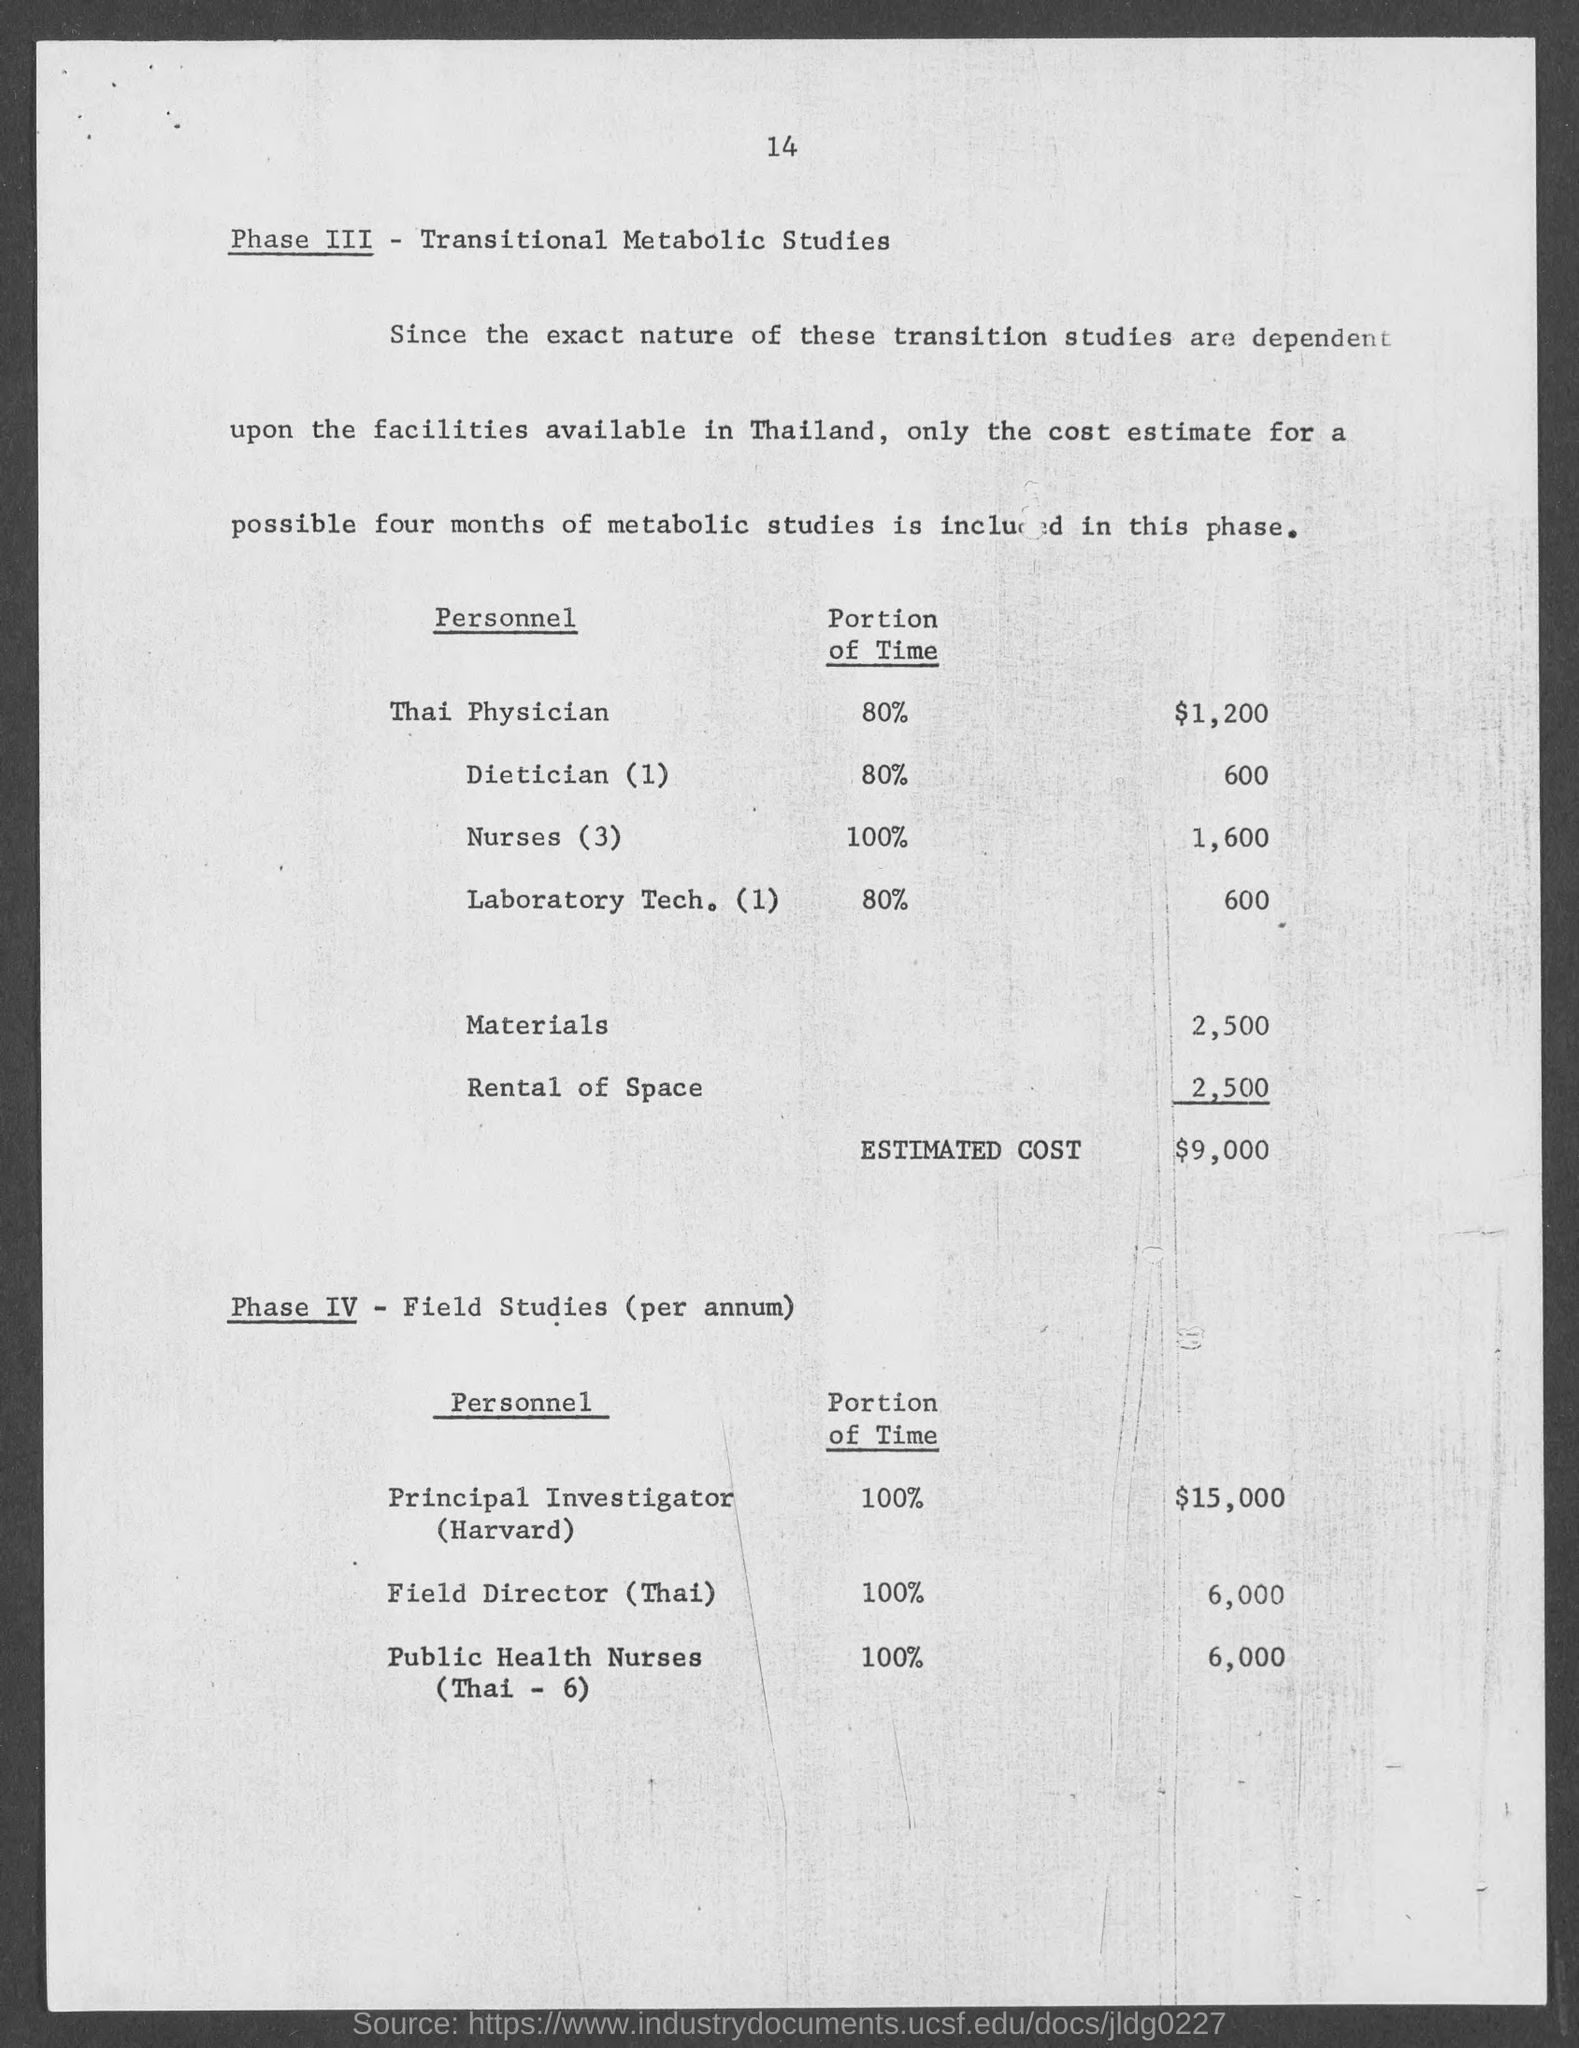What can you infer about the significance of Phase III in the overall project? Phase III seems to focus on Transitional Metabolic Studies, intimating a crucial developmental stage in the research. Its dependence on Thai facilities and allocation of substantial time to local staff including nurses, a dietician, and a laboratory technician suggests it is a highly involved phase that may interface directly with study subjects and could be central to the operational success of the entire project. 